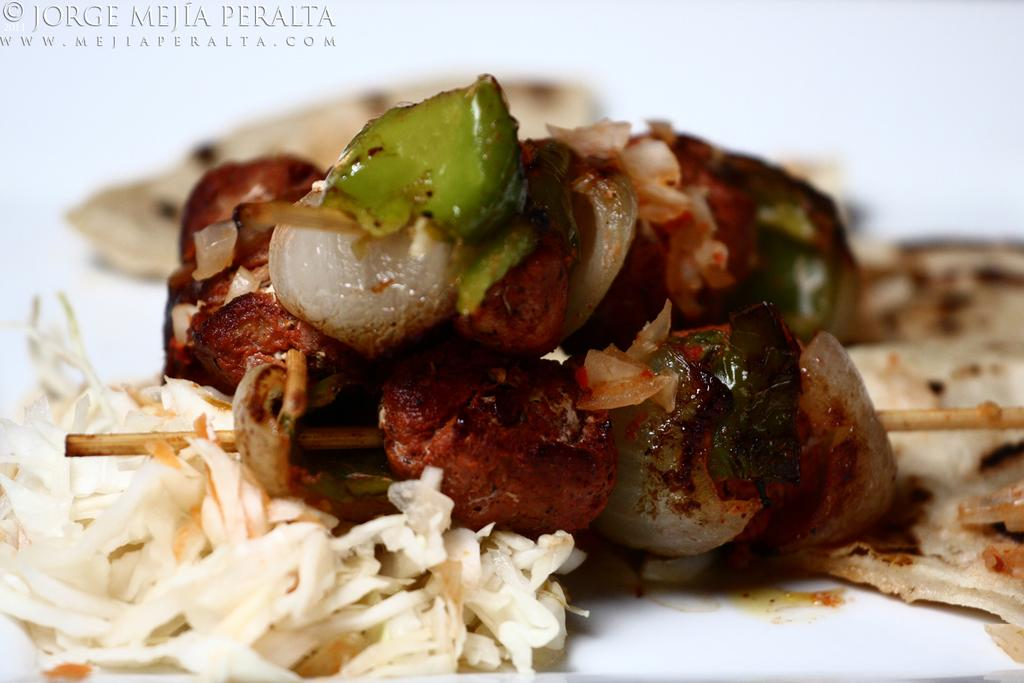What is the focus of the image? The image is zoomed in, with the focus on food items in the center. What can be observed about the food items in the image? The food items are placed on a white object. Is there any additional information or branding in the image? Yes, there is a watermark in the top left corner of the image. What type of hill can be seen in the middle of the image? There is no hill present in the image; it features food items placed on a white object. What type of meal is being prepared in the image? The image does not show a meal being prepared; it only shows food items placed on a white object. 